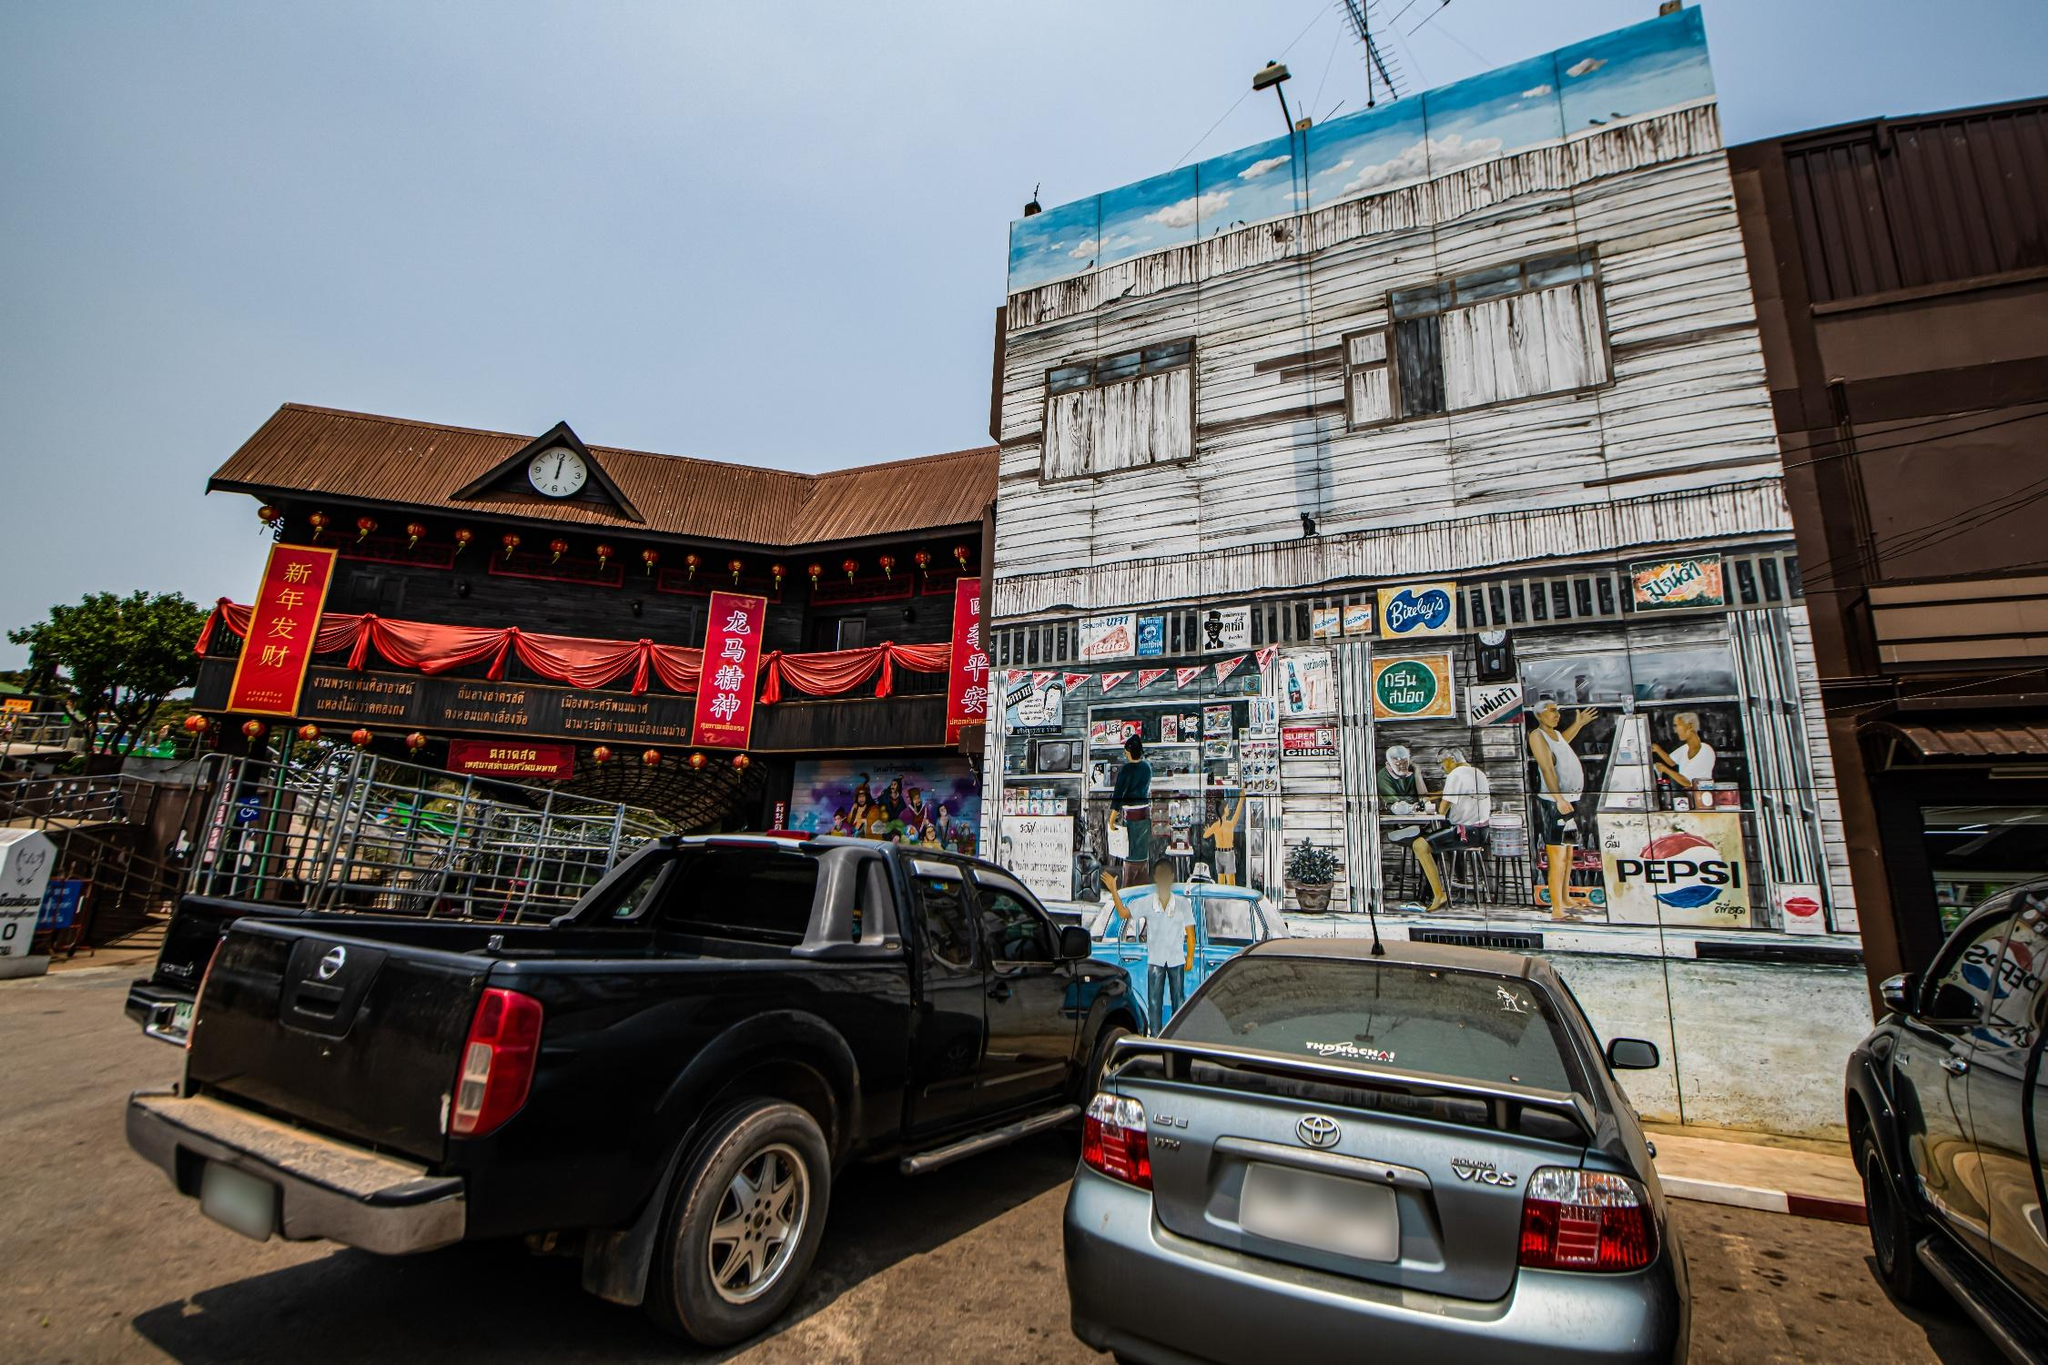Can you elaborate on the elements of the picture provided? The image captures a vibrant street scene in Thailand. Dominating the foreground are two vehicles, a black pickup truck and a silver Toyota car, parked neatly on the side of the road. The road itself, a central character in this tableau, is lined with a variety of buildings. 

On one side, there's a wooden building, its roof shielded from the elements by a blue tarp. Its rustic charm contrasts with the modernity of another building further down the road, which sports a Pepsi sign, a universal symbol of contemporary consumer culture. 

Adding a festive touch to the scene are red banners. They hang from the buildings, fluttering slightly, perhaps in a gentle breeze. Their bright color stands out against the backdrop of the buildings and the clear blue sky above. 

In the distance, trees rise, their green foliage adding a touch of nature to this urban landscape. Their presence softens the cityscape, providing a balance between the man-made and the natural. 

Despite the absence of people, the image is full of life. The parked vehicles suggest recent activity, the banners hint at a celebration or event, and the variety of buildings tell a story of a community living and working together. It's a snapshot of everyday life, a moment frozen in time in a bustling Thai street. 